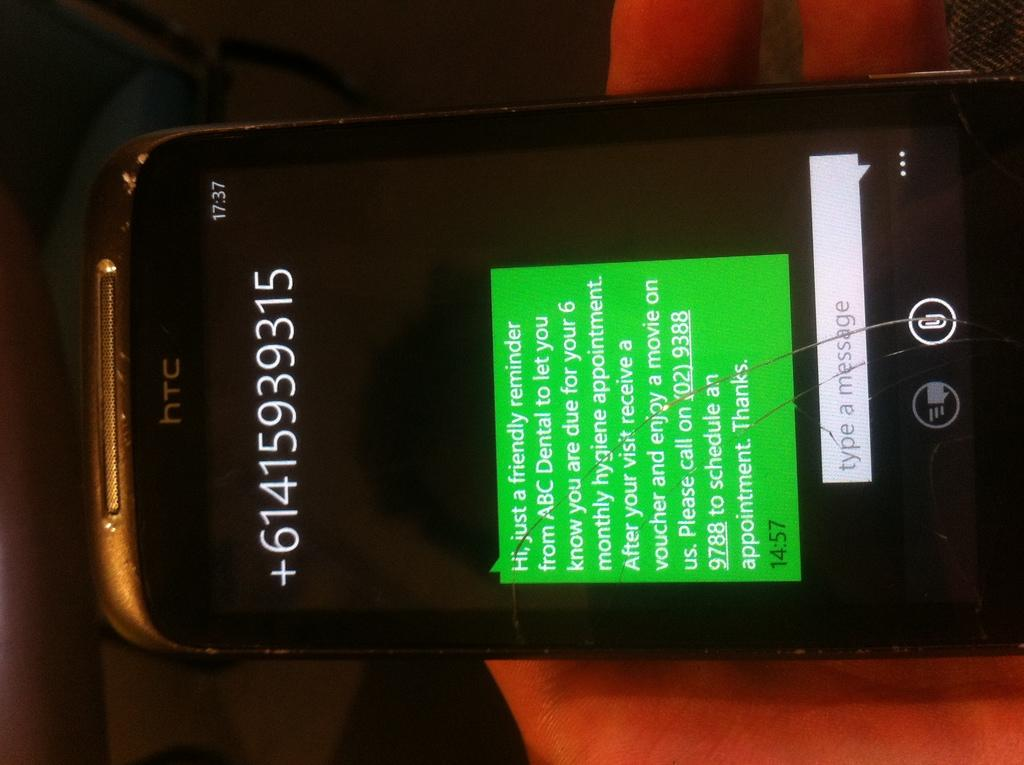Provide a one-sentence caption for the provided image. A cell phone with a phone number across the top and a message from ABC saying it is a friendly reminder of an upcoming appointment. 